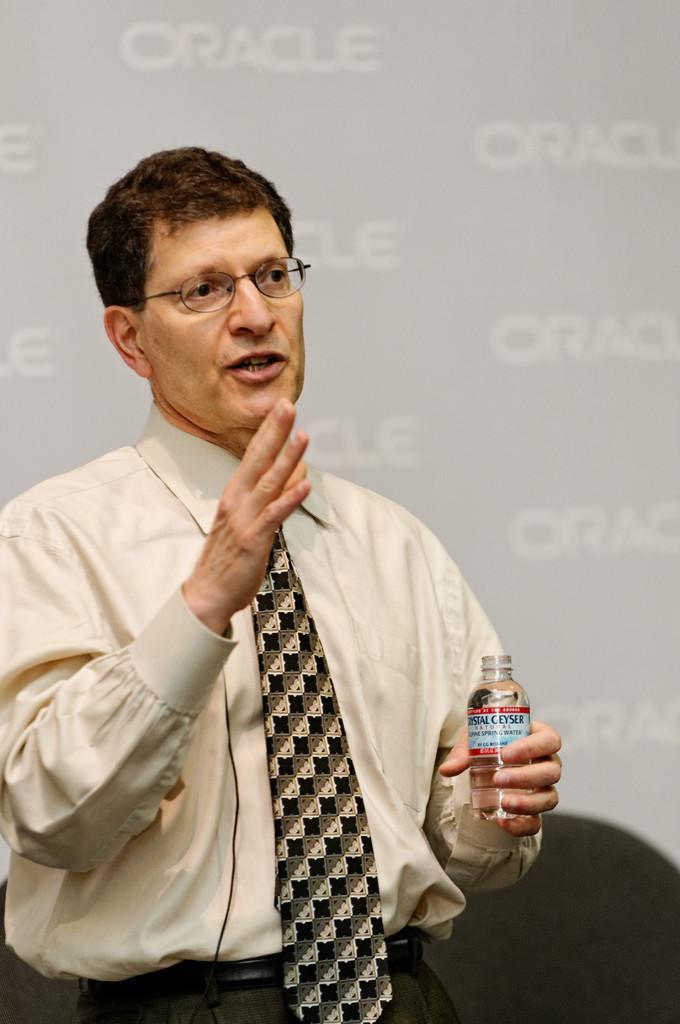Describe this image in one or two sentences. In the image we can see there is a man standing and he is holding bottle in his hand. He is wearing tie and spectacles. Behind there is a banner on the wall and its written ¨ORACLE¨ on the banner. 